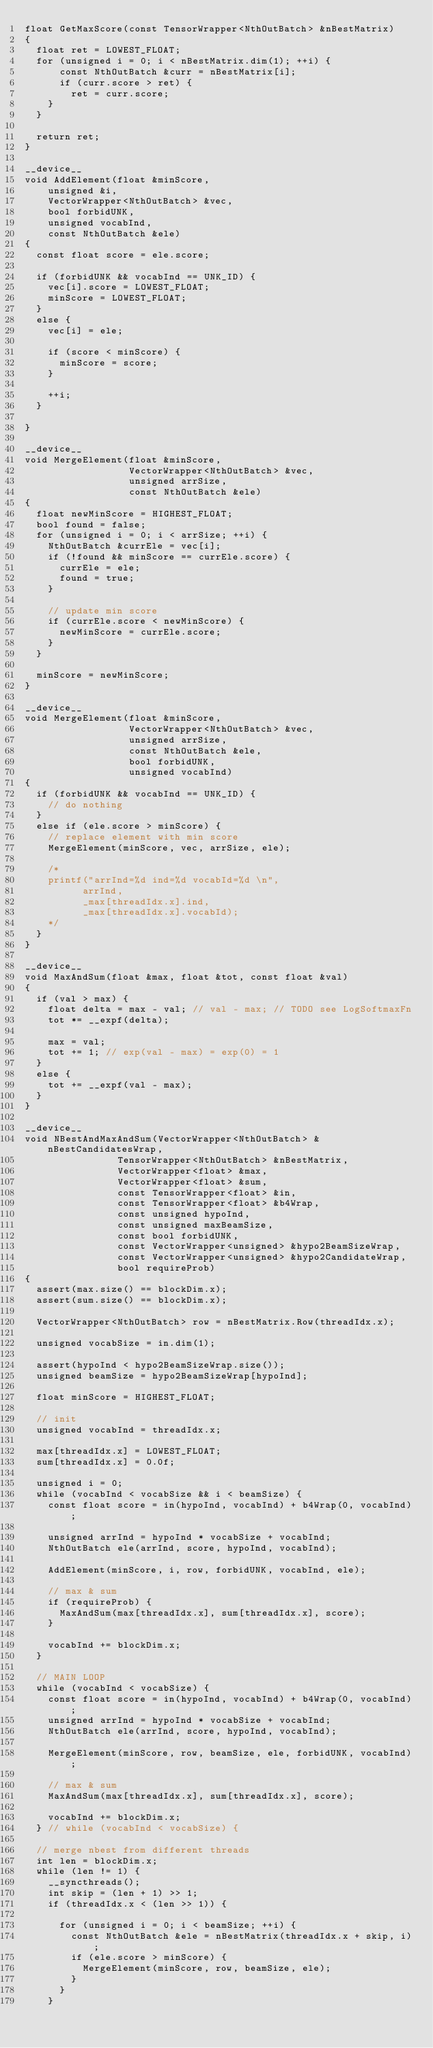Convert code to text. <code><loc_0><loc_0><loc_500><loc_500><_Cuda_>float GetMaxScore(const TensorWrapper<NthOutBatch> &nBestMatrix)
{
  float ret = LOWEST_FLOAT;
  for (unsigned i = 0; i < nBestMatrix.dim(1); ++i) {
      const NthOutBatch &curr = nBestMatrix[i];
      if (curr.score > ret) {
        ret = curr.score;
    }
  }

  return ret;
}

__device__
void AddElement(float &minScore,
    unsigned &i,
    VectorWrapper<NthOutBatch> &vec,
    bool forbidUNK,
    unsigned vocabInd,
    const NthOutBatch &ele)
{
  const float score = ele.score;

  if (forbidUNK && vocabInd == UNK_ID) {
    vec[i].score = LOWEST_FLOAT;
    minScore = LOWEST_FLOAT;
  }
  else {
    vec[i] = ele;

    if (score < minScore) {
      minScore = score;
    }

    ++i;
  }

}

__device__
void MergeElement(float &minScore,
                  VectorWrapper<NthOutBatch> &vec,
                  unsigned arrSize,
                  const NthOutBatch &ele)
{
  float newMinScore = HIGHEST_FLOAT;
  bool found = false;
  for (unsigned i = 0; i < arrSize; ++i) {
    NthOutBatch &currEle = vec[i];
    if (!found && minScore == currEle.score) {
      currEle = ele;
      found = true;
    }

    // update min score
    if (currEle.score < newMinScore) {
      newMinScore = currEle.score;
    }
  }

  minScore = newMinScore;
}

__device__
void MergeElement(float &minScore,
                  VectorWrapper<NthOutBatch> &vec,
                  unsigned arrSize,
                  const NthOutBatch &ele,
                  bool forbidUNK,
                  unsigned vocabInd)
{
  if (forbidUNK && vocabInd == UNK_ID) {
    // do nothing
  }
  else if (ele.score > minScore) {
    // replace element with min score
    MergeElement(minScore, vec, arrSize, ele);

    /*
    printf("arrInd=%d ind=%d vocabId=%d \n",
          arrInd,
          _max[threadIdx.x].ind,
          _max[threadIdx.x].vocabId);
    */
  }
}

__device__
void MaxAndSum(float &max, float &tot, const float &val)
{
  if (val > max) {
    float delta = max - val; // val - max; // TODO see LogSoftmaxFn
    tot *= __expf(delta);

    max = val;
    tot += 1; // exp(val - max) = exp(0) = 1
  }
  else {
    tot += __expf(val - max);
  }
}

__device__
void NBestAndMaxAndSum(VectorWrapper<NthOutBatch> &nBestCandidatesWrap,
                TensorWrapper<NthOutBatch> &nBestMatrix,
                VectorWrapper<float> &max,
                VectorWrapper<float> &sum,
                const TensorWrapper<float> &in,
                const TensorWrapper<float> &b4Wrap,
                const unsigned hypoInd,
                const unsigned maxBeamSize,
                const bool forbidUNK,
                const VectorWrapper<unsigned> &hypo2BeamSizeWrap,
                const VectorWrapper<unsigned> &hypo2CandidateWrap,
                bool requireProb)
{
  assert(max.size() == blockDim.x);
  assert(sum.size() == blockDim.x);

  VectorWrapper<NthOutBatch> row = nBestMatrix.Row(threadIdx.x);

  unsigned vocabSize = in.dim(1);

  assert(hypoInd < hypo2BeamSizeWrap.size());
  unsigned beamSize = hypo2BeamSizeWrap[hypoInd];

  float minScore = HIGHEST_FLOAT;

  // init
  unsigned vocabInd = threadIdx.x;

  max[threadIdx.x] = LOWEST_FLOAT;
  sum[threadIdx.x] = 0.0f;

  unsigned i = 0;
  while (vocabInd < vocabSize && i < beamSize) {
    const float score = in(hypoInd, vocabInd) + b4Wrap(0, vocabInd);

    unsigned arrInd = hypoInd * vocabSize + vocabInd;
    NthOutBatch ele(arrInd, score, hypoInd, vocabInd);

    AddElement(minScore, i, row, forbidUNK, vocabInd, ele);

    // max & sum
    if (requireProb) {
      MaxAndSum(max[threadIdx.x], sum[threadIdx.x], score);
    }

    vocabInd += blockDim.x;
  }

  // MAIN LOOP
  while (vocabInd < vocabSize) {
    const float score = in(hypoInd, vocabInd) + b4Wrap(0, vocabInd);
    unsigned arrInd = hypoInd * vocabSize + vocabInd;
    NthOutBatch ele(arrInd, score, hypoInd, vocabInd);

    MergeElement(minScore, row, beamSize, ele, forbidUNK, vocabInd);

    // max & sum
    MaxAndSum(max[threadIdx.x], sum[threadIdx.x], score);

    vocabInd += blockDim.x;
  } // while (vocabInd < vocabSize) {

  // merge nbest from different threads
  int len = blockDim.x;
  while (len != 1) {
    __syncthreads();
    int skip = (len + 1) >> 1;
    if (threadIdx.x < (len >> 1)) {

      for (unsigned i = 0; i < beamSize; ++i) {
        const NthOutBatch &ele = nBestMatrix(threadIdx.x + skip, i);
        if (ele.score > minScore) {
          MergeElement(minScore, row, beamSize, ele);
        }
      }
    }</code> 